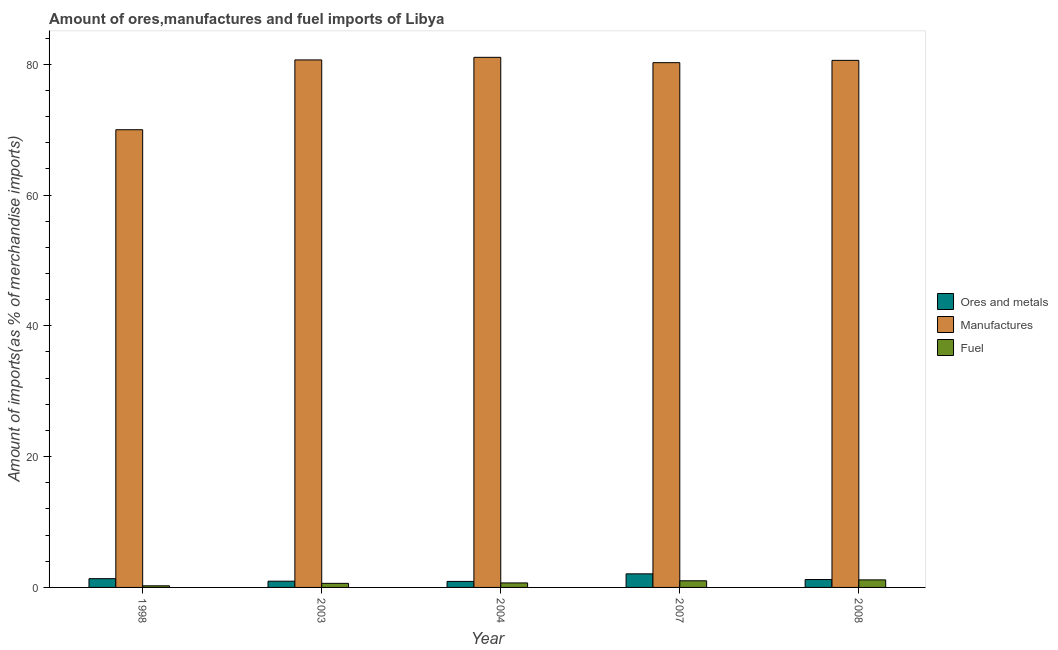How many different coloured bars are there?
Offer a terse response. 3. Are the number of bars per tick equal to the number of legend labels?
Offer a terse response. Yes. How many bars are there on the 2nd tick from the left?
Keep it short and to the point. 3. In how many cases, is the number of bars for a given year not equal to the number of legend labels?
Your answer should be very brief. 0. What is the percentage of fuel imports in 2004?
Provide a short and direct response. 0.69. Across all years, what is the maximum percentage of manufactures imports?
Your answer should be compact. 81.06. Across all years, what is the minimum percentage of fuel imports?
Provide a short and direct response. 0.25. In which year was the percentage of fuel imports minimum?
Offer a very short reply. 1998. What is the total percentage of manufactures imports in the graph?
Your answer should be compact. 392.55. What is the difference between the percentage of fuel imports in 2003 and that in 2004?
Keep it short and to the point. -0.07. What is the difference between the percentage of ores and metals imports in 1998 and the percentage of manufactures imports in 2004?
Offer a very short reply. 0.42. What is the average percentage of fuel imports per year?
Offer a terse response. 0.75. In how many years, is the percentage of ores and metals imports greater than 64 %?
Keep it short and to the point. 0. What is the ratio of the percentage of manufactures imports in 1998 to that in 2004?
Keep it short and to the point. 0.86. Is the difference between the percentage of fuel imports in 1998 and 2007 greater than the difference between the percentage of manufactures imports in 1998 and 2007?
Give a very brief answer. No. What is the difference between the highest and the second highest percentage of fuel imports?
Offer a very short reply. 0.14. What is the difference between the highest and the lowest percentage of fuel imports?
Ensure brevity in your answer.  0.9. What does the 1st bar from the left in 2003 represents?
Your answer should be compact. Ores and metals. What does the 3rd bar from the right in 2008 represents?
Ensure brevity in your answer.  Ores and metals. Is it the case that in every year, the sum of the percentage of ores and metals imports and percentage of manufactures imports is greater than the percentage of fuel imports?
Offer a very short reply. Yes. How many bars are there?
Your answer should be very brief. 15. How many years are there in the graph?
Your response must be concise. 5. What is the difference between two consecutive major ticks on the Y-axis?
Provide a short and direct response. 20. Does the graph contain grids?
Provide a short and direct response. No. How are the legend labels stacked?
Provide a succinct answer. Vertical. What is the title of the graph?
Ensure brevity in your answer.  Amount of ores,manufactures and fuel imports of Libya. What is the label or title of the X-axis?
Make the answer very short. Year. What is the label or title of the Y-axis?
Your response must be concise. Amount of imports(as % of merchandise imports). What is the Amount of imports(as % of merchandise imports) in Ores and metals in 1998?
Provide a short and direct response. 1.34. What is the Amount of imports(as % of merchandise imports) of Manufactures in 1998?
Ensure brevity in your answer.  69.99. What is the Amount of imports(as % of merchandise imports) of Fuel in 1998?
Keep it short and to the point. 0.25. What is the Amount of imports(as % of merchandise imports) in Ores and metals in 2003?
Provide a succinct answer. 0.95. What is the Amount of imports(as % of merchandise imports) of Manufactures in 2003?
Provide a short and direct response. 80.66. What is the Amount of imports(as % of merchandise imports) in Fuel in 2003?
Provide a succinct answer. 0.62. What is the Amount of imports(as % of merchandise imports) in Ores and metals in 2004?
Offer a terse response. 0.92. What is the Amount of imports(as % of merchandise imports) in Manufactures in 2004?
Give a very brief answer. 81.06. What is the Amount of imports(as % of merchandise imports) of Fuel in 2004?
Ensure brevity in your answer.  0.69. What is the Amount of imports(as % of merchandise imports) in Ores and metals in 2007?
Keep it short and to the point. 2.08. What is the Amount of imports(as % of merchandise imports) in Manufactures in 2007?
Your answer should be very brief. 80.24. What is the Amount of imports(as % of merchandise imports) of Fuel in 2007?
Make the answer very short. 1.02. What is the Amount of imports(as % of merchandise imports) in Ores and metals in 2008?
Make the answer very short. 1.21. What is the Amount of imports(as % of merchandise imports) of Manufactures in 2008?
Ensure brevity in your answer.  80.59. What is the Amount of imports(as % of merchandise imports) in Fuel in 2008?
Give a very brief answer. 1.15. Across all years, what is the maximum Amount of imports(as % of merchandise imports) in Ores and metals?
Give a very brief answer. 2.08. Across all years, what is the maximum Amount of imports(as % of merchandise imports) in Manufactures?
Your response must be concise. 81.06. Across all years, what is the maximum Amount of imports(as % of merchandise imports) of Fuel?
Provide a short and direct response. 1.15. Across all years, what is the minimum Amount of imports(as % of merchandise imports) of Ores and metals?
Your answer should be very brief. 0.92. Across all years, what is the minimum Amount of imports(as % of merchandise imports) of Manufactures?
Keep it short and to the point. 69.99. Across all years, what is the minimum Amount of imports(as % of merchandise imports) in Fuel?
Offer a very short reply. 0.25. What is the total Amount of imports(as % of merchandise imports) in Ores and metals in the graph?
Provide a short and direct response. 6.5. What is the total Amount of imports(as % of merchandise imports) of Manufactures in the graph?
Your answer should be very brief. 392.55. What is the total Amount of imports(as % of merchandise imports) in Fuel in the graph?
Your response must be concise. 3.73. What is the difference between the Amount of imports(as % of merchandise imports) in Ores and metals in 1998 and that in 2003?
Provide a succinct answer. 0.39. What is the difference between the Amount of imports(as % of merchandise imports) in Manufactures in 1998 and that in 2003?
Your answer should be very brief. -10.68. What is the difference between the Amount of imports(as % of merchandise imports) of Fuel in 1998 and that in 2003?
Ensure brevity in your answer.  -0.37. What is the difference between the Amount of imports(as % of merchandise imports) in Ores and metals in 1998 and that in 2004?
Keep it short and to the point. 0.42. What is the difference between the Amount of imports(as % of merchandise imports) in Manufactures in 1998 and that in 2004?
Your answer should be very brief. -11.07. What is the difference between the Amount of imports(as % of merchandise imports) in Fuel in 1998 and that in 2004?
Provide a short and direct response. -0.44. What is the difference between the Amount of imports(as % of merchandise imports) of Ores and metals in 1998 and that in 2007?
Keep it short and to the point. -0.74. What is the difference between the Amount of imports(as % of merchandise imports) of Manufactures in 1998 and that in 2007?
Your answer should be very brief. -10.26. What is the difference between the Amount of imports(as % of merchandise imports) of Fuel in 1998 and that in 2007?
Give a very brief answer. -0.77. What is the difference between the Amount of imports(as % of merchandise imports) in Ores and metals in 1998 and that in 2008?
Make the answer very short. 0.13. What is the difference between the Amount of imports(as % of merchandise imports) in Manufactures in 1998 and that in 2008?
Offer a very short reply. -10.61. What is the difference between the Amount of imports(as % of merchandise imports) in Fuel in 1998 and that in 2008?
Provide a short and direct response. -0.9. What is the difference between the Amount of imports(as % of merchandise imports) of Ores and metals in 2003 and that in 2004?
Offer a very short reply. 0.03. What is the difference between the Amount of imports(as % of merchandise imports) in Manufactures in 2003 and that in 2004?
Ensure brevity in your answer.  -0.4. What is the difference between the Amount of imports(as % of merchandise imports) in Fuel in 2003 and that in 2004?
Your answer should be very brief. -0.07. What is the difference between the Amount of imports(as % of merchandise imports) of Ores and metals in 2003 and that in 2007?
Make the answer very short. -1.12. What is the difference between the Amount of imports(as % of merchandise imports) in Manufactures in 2003 and that in 2007?
Offer a very short reply. 0.42. What is the difference between the Amount of imports(as % of merchandise imports) of Fuel in 2003 and that in 2007?
Give a very brief answer. -0.39. What is the difference between the Amount of imports(as % of merchandise imports) of Ores and metals in 2003 and that in 2008?
Give a very brief answer. -0.26. What is the difference between the Amount of imports(as % of merchandise imports) of Manufactures in 2003 and that in 2008?
Your response must be concise. 0.07. What is the difference between the Amount of imports(as % of merchandise imports) in Fuel in 2003 and that in 2008?
Provide a succinct answer. -0.53. What is the difference between the Amount of imports(as % of merchandise imports) in Ores and metals in 2004 and that in 2007?
Make the answer very short. -1.16. What is the difference between the Amount of imports(as % of merchandise imports) in Manufactures in 2004 and that in 2007?
Ensure brevity in your answer.  0.82. What is the difference between the Amount of imports(as % of merchandise imports) of Fuel in 2004 and that in 2007?
Keep it short and to the point. -0.33. What is the difference between the Amount of imports(as % of merchandise imports) of Ores and metals in 2004 and that in 2008?
Give a very brief answer. -0.29. What is the difference between the Amount of imports(as % of merchandise imports) of Manufactures in 2004 and that in 2008?
Ensure brevity in your answer.  0.47. What is the difference between the Amount of imports(as % of merchandise imports) of Fuel in 2004 and that in 2008?
Offer a very short reply. -0.46. What is the difference between the Amount of imports(as % of merchandise imports) of Ores and metals in 2007 and that in 2008?
Provide a short and direct response. 0.87. What is the difference between the Amount of imports(as % of merchandise imports) of Manufactures in 2007 and that in 2008?
Your response must be concise. -0.35. What is the difference between the Amount of imports(as % of merchandise imports) of Fuel in 2007 and that in 2008?
Keep it short and to the point. -0.14. What is the difference between the Amount of imports(as % of merchandise imports) of Ores and metals in 1998 and the Amount of imports(as % of merchandise imports) of Manufactures in 2003?
Provide a succinct answer. -79.32. What is the difference between the Amount of imports(as % of merchandise imports) in Ores and metals in 1998 and the Amount of imports(as % of merchandise imports) in Fuel in 2003?
Offer a very short reply. 0.72. What is the difference between the Amount of imports(as % of merchandise imports) of Manufactures in 1998 and the Amount of imports(as % of merchandise imports) of Fuel in 2003?
Provide a succinct answer. 69.36. What is the difference between the Amount of imports(as % of merchandise imports) of Ores and metals in 1998 and the Amount of imports(as % of merchandise imports) of Manufactures in 2004?
Provide a short and direct response. -79.72. What is the difference between the Amount of imports(as % of merchandise imports) in Ores and metals in 1998 and the Amount of imports(as % of merchandise imports) in Fuel in 2004?
Make the answer very short. 0.65. What is the difference between the Amount of imports(as % of merchandise imports) of Manufactures in 1998 and the Amount of imports(as % of merchandise imports) of Fuel in 2004?
Ensure brevity in your answer.  69.3. What is the difference between the Amount of imports(as % of merchandise imports) in Ores and metals in 1998 and the Amount of imports(as % of merchandise imports) in Manufactures in 2007?
Ensure brevity in your answer.  -78.9. What is the difference between the Amount of imports(as % of merchandise imports) of Ores and metals in 1998 and the Amount of imports(as % of merchandise imports) of Fuel in 2007?
Your answer should be very brief. 0.33. What is the difference between the Amount of imports(as % of merchandise imports) of Manufactures in 1998 and the Amount of imports(as % of merchandise imports) of Fuel in 2007?
Your response must be concise. 68.97. What is the difference between the Amount of imports(as % of merchandise imports) of Ores and metals in 1998 and the Amount of imports(as % of merchandise imports) of Manufactures in 2008?
Keep it short and to the point. -79.25. What is the difference between the Amount of imports(as % of merchandise imports) in Ores and metals in 1998 and the Amount of imports(as % of merchandise imports) in Fuel in 2008?
Ensure brevity in your answer.  0.19. What is the difference between the Amount of imports(as % of merchandise imports) of Manufactures in 1998 and the Amount of imports(as % of merchandise imports) of Fuel in 2008?
Give a very brief answer. 68.83. What is the difference between the Amount of imports(as % of merchandise imports) of Ores and metals in 2003 and the Amount of imports(as % of merchandise imports) of Manufactures in 2004?
Provide a short and direct response. -80.11. What is the difference between the Amount of imports(as % of merchandise imports) in Ores and metals in 2003 and the Amount of imports(as % of merchandise imports) in Fuel in 2004?
Your answer should be very brief. 0.26. What is the difference between the Amount of imports(as % of merchandise imports) in Manufactures in 2003 and the Amount of imports(as % of merchandise imports) in Fuel in 2004?
Your answer should be compact. 79.97. What is the difference between the Amount of imports(as % of merchandise imports) of Ores and metals in 2003 and the Amount of imports(as % of merchandise imports) of Manufactures in 2007?
Offer a very short reply. -79.29. What is the difference between the Amount of imports(as % of merchandise imports) of Ores and metals in 2003 and the Amount of imports(as % of merchandise imports) of Fuel in 2007?
Provide a succinct answer. -0.06. What is the difference between the Amount of imports(as % of merchandise imports) in Manufactures in 2003 and the Amount of imports(as % of merchandise imports) in Fuel in 2007?
Offer a very short reply. 79.65. What is the difference between the Amount of imports(as % of merchandise imports) in Ores and metals in 2003 and the Amount of imports(as % of merchandise imports) in Manufactures in 2008?
Make the answer very short. -79.64. What is the difference between the Amount of imports(as % of merchandise imports) of Ores and metals in 2003 and the Amount of imports(as % of merchandise imports) of Fuel in 2008?
Your response must be concise. -0.2. What is the difference between the Amount of imports(as % of merchandise imports) in Manufactures in 2003 and the Amount of imports(as % of merchandise imports) in Fuel in 2008?
Your response must be concise. 79.51. What is the difference between the Amount of imports(as % of merchandise imports) of Ores and metals in 2004 and the Amount of imports(as % of merchandise imports) of Manufactures in 2007?
Your answer should be compact. -79.32. What is the difference between the Amount of imports(as % of merchandise imports) of Ores and metals in 2004 and the Amount of imports(as % of merchandise imports) of Fuel in 2007?
Provide a succinct answer. -0.1. What is the difference between the Amount of imports(as % of merchandise imports) in Manufactures in 2004 and the Amount of imports(as % of merchandise imports) in Fuel in 2007?
Your response must be concise. 80.04. What is the difference between the Amount of imports(as % of merchandise imports) of Ores and metals in 2004 and the Amount of imports(as % of merchandise imports) of Manufactures in 2008?
Offer a terse response. -79.67. What is the difference between the Amount of imports(as % of merchandise imports) in Ores and metals in 2004 and the Amount of imports(as % of merchandise imports) in Fuel in 2008?
Provide a succinct answer. -0.23. What is the difference between the Amount of imports(as % of merchandise imports) in Manufactures in 2004 and the Amount of imports(as % of merchandise imports) in Fuel in 2008?
Your response must be concise. 79.91. What is the difference between the Amount of imports(as % of merchandise imports) in Ores and metals in 2007 and the Amount of imports(as % of merchandise imports) in Manufactures in 2008?
Give a very brief answer. -78.52. What is the difference between the Amount of imports(as % of merchandise imports) of Manufactures in 2007 and the Amount of imports(as % of merchandise imports) of Fuel in 2008?
Offer a very short reply. 79.09. What is the average Amount of imports(as % of merchandise imports) in Ores and metals per year?
Provide a short and direct response. 1.3. What is the average Amount of imports(as % of merchandise imports) of Manufactures per year?
Provide a short and direct response. 78.51. What is the average Amount of imports(as % of merchandise imports) of Fuel per year?
Make the answer very short. 0.75. In the year 1998, what is the difference between the Amount of imports(as % of merchandise imports) of Ores and metals and Amount of imports(as % of merchandise imports) of Manufactures?
Ensure brevity in your answer.  -68.65. In the year 1998, what is the difference between the Amount of imports(as % of merchandise imports) in Ores and metals and Amount of imports(as % of merchandise imports) in Fuel?
Keep it short and to the point. 1.09. In the year 1998, what is the difference between the Amount of imports(as % of merchandise imports) in Manufactures and Amount of imports(as % of merchandise imports) in Fuel?
Your response must be concise. 69.74. In the year 2003, what is the difference between the Amount of imports(as % of merchandise imports) in Ores and metals and Amount of imports(as % of merchandise imports) in Manufactures?
Give a very brief answer. -79.71. In the year 2003, what is the difference between the Amount of imports(as % of merchandise imports) in Ores and metals and Amount of imports(as % of merchandise imports) in Fuel?
Ensure brevity in your answer.  0.33. In the year 2003, what is the difference between the Amount of imports(as % of merchandise imports) of Manufactures and Amount of imports(as % of merchandise imports) of Fuel?
Offer a very short reply. 80.04. In the year 2004, what is the difference between the Amount of imports(as % of merchandise imports) of Ores and metals and Amount of imports(as % of merchandise imports) of Manufactures?
Your response must be concise. -80.14. In the year 2004, what is the difference between the Amount of imports(as % of merchandise imports) in Ores and metals and Amount of imports(as % of merchandise imports) in Fuel?
Keep it short and to the point. 0.23. In the year 2004, what is the difference between the Amount of imports(as % of merchandise imports) in Manufactures and Amount of imports(as % of merchandise imports) in Fuel?
Your answer should be compact. 80.37. In the year 2007, what is the difference between the Amount of imports(as % of merchandise imports) of Ores and metals and Amount of imports(as % of merchandise imports) of Manufactures?
Offer a very short reply. -78.17. In the year 2007, what is the difference between the Amount of imports(as % of merchandise imports) in Ores and metals and Amount of imports(as % of merchandise imports) in Fuel?
Give a very brief answer. 1.06. In the year 2007, what is the difference between the Amount of imports(as % of merchandise imports) of Manufactures and Amount of imports(as % of merchandise imports) of Fuel?
Keep it short and to the point. 79.23. In the year 2008, what is the difference between the Amount of imports(as % of merchandise imports) of Ores and metals and Amount of imports(as % of merchandise imports) of Manufactures?
Your answer should be compact. -79.38. In the year 2008, what is the difference between the Amount of imports(as % of merchandise imports) in Ores and metals and Amount of imports(as % of merchandise imports) in Fuel?
Make the answer very short. 0.06. In the year 2008, what is the difference between the Amount of imports(as % of merchandise imports) in Manufactures and Amount of imports(as % of merchandise imports) in Fuel?
Provide a short and direct response. 79.44. What is the ratio of the Amount of imports(as % of merchandise imports) of Ores and metals in 1998 to that in 2003?
Keep it short and to the point. 1.41. What is the ratio of the Amount of imports(as % of merchandise imports) of Manufactures in 1998 to that in 2003?
Offer a very short reply. 0.87. What is the ratio of the Amount of imports(as % of merchandise imports) in Fuel in 1998 to that in 2003?
Provide a succinct answer. 0.4. What is the ratio of the Amount of imports(as % of merchandise imports) of Ores and metals in 1998 to that in 2004?
Make the answer very short. 1.46. What is the ratio of the Amount of imports(as % of merchandise imports) in Manufactures in 1998 to that in 2004?
Provide a succinct answer. 0.86. What is the ratio of the Amount of imports(as % of merchandise imports) of Fuel in 1998 to that in 2004?
Keep it short and to the point. 0.36. What is the ratio of the Amount of imports(as % of merchandise imports) of Ores and metals in 1998 to that in 2007?
Ensure brevity in your answer.  0.65. What is the ratio of the Amount of imports(as % of merchandise imports) in Manufactures in 1998 to that in 2007?
Your answer should be very brief. 0.87. What is the ratio of the Amount of imports(as % of merchandise imports) in Fuel in 1998 to that in 2007?
Your answer should be compact. 0.24. What is the ratio of the Amount of imports(as % of merchandise imports) in Ores and metals in 1998 to that in 2008?
Provide a succinct answer. 1.11. What is the ratio of the Amount of imports(as % of merchandise imports) of Manufactures in 1998 to that in 2008?
Give a very brief answer. 0.87. What is the ratio of the Amount of imports(as % of merchandise imports) of Fuel in 1998 to that in 2008?
Your answer should be compact. 0.22. What is the ratio of the Amount of imports(as % of merchandise imports) of Ores and metals in 2003 to that in 2004?
Offer a terse response. 1.03. What is the ratio of the Amount of imports(as % of merchandise imports) of Fuel in 2003 to that in 2004?
Ensure brevity in your answer.  0.9. What is the ratio of the Amount of imports(as % of merchandise imports) of Ores and metals in 2003 to that in 2007?
Offer a terse response. 0.46. What is the ratio of the Amount of imports(as % of merchandise imports) of Manufactures in 2003 to that in 2007?
Your answer should be compact. 1.01. What is the ratio of the Amount of imports(as % of merchandise imports) in Fuel in 2003 to that in 2007?
Your answer should be compact. 0.61. What is the ratio of the Amount of imports(as % of merchandise imports) of Ores and metals in 2003 to that in 2008?
Give a very brief answer. 0.79. What is the ratio of the Amount of imports(as % of merchandise imports) of Manufactures in 2003 to that in 2008?
Provide a succinct answer. 1. What is the ratio of the Amount of imports(as % of merchandise imports) of Fuel in 2003 to that in 2008?
Your answer should be compact. 0.54. What is the ratio of the Amount of imports(as % of merchandise imports) of Ores and metals in 2004 to that in 2007?
Ensure brevity in your answer.  0.44. What is the ratio of the Amount of imports(as % of merchandise imports) of Manufactures in 2004 to that in 2007?
Provide a short and direct response. 1.01. What is the ratio of the Amount of imports(as % of merchandise imports) of Fuel in 2004 to that in 2007?
Offer a very short reply. 0.68. What is the ratio of the Amount of imports(as % of merchandise imports) of Ores and metals in 2004 to that in 2008?
Your answer should be compact. 0.76. What is the ratio of the Amount of imports(as % of merchandise imports) in Manufactures in 2004 to that in 2008?
Offer a very short reply. 1.01. What is the ratio of the Amount of imports(as % of merchandise imports) of Fuel in 2004 to that in 2008?
Your response must be concise. 0.6. What is the ratio of the Amount of imports(as % of merchandise imports) of Ores and metals in 2007 to that in 2008?
Your answer should be compact. 1.72. What is the ratio of the Amount of imports(as % of merchandise imports) of Fuel in 2007 to that in 2008?
Provide a short and direct response. 0.88. What is the difference between the highest and the second highest Amount of imports(as % of merchandise imports) of Ores and metals?
Your answer should be compact. 0.74. What is the difference between the highest and the second highest Amount of imports(as % of merchandise imports) in Manufactures?
Your answer should be compact. 0.4. What is the difference between the highest and the second highest Amount of imports(as % of merchandise imports) in Fuel?
Provide a succinct answer. 0.14. What is the difference between the highest and the lowest Amount of imports(as % of merchandise imports) in Ores and metals?
Ensure brevity in your answer.  1.16. What is the difference between the highest and the lowest Amount of imports(as % of merchandise imports) of Manufactures?
Your answer should be compact. 11.07. What is the difference between the highest and the lowest Amount of imports(as % of merchandise imports) in Fuel?
Make the answer very short. 0.9. 